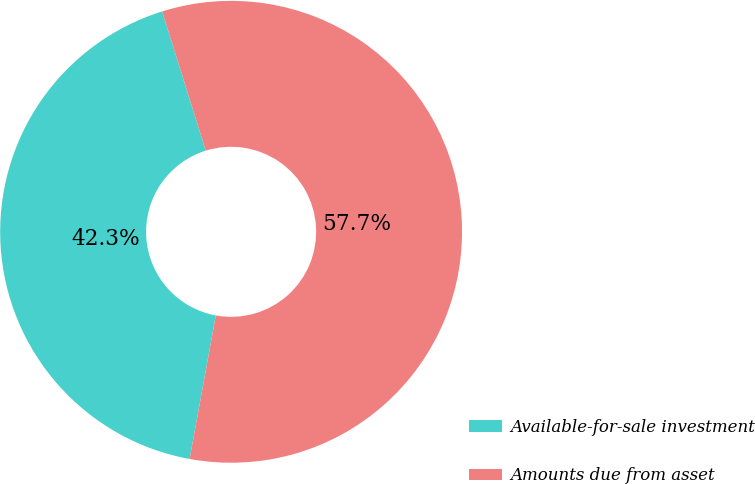Convert chart to OTSL. <chart><loc_0><loc_0><loc_500><loc_500><pie_chart><fcel>Available-for-sale investment<fcel>Amounts due from asset<nl><fcel>42.3%<fcel>57.7%<nl></chart> 